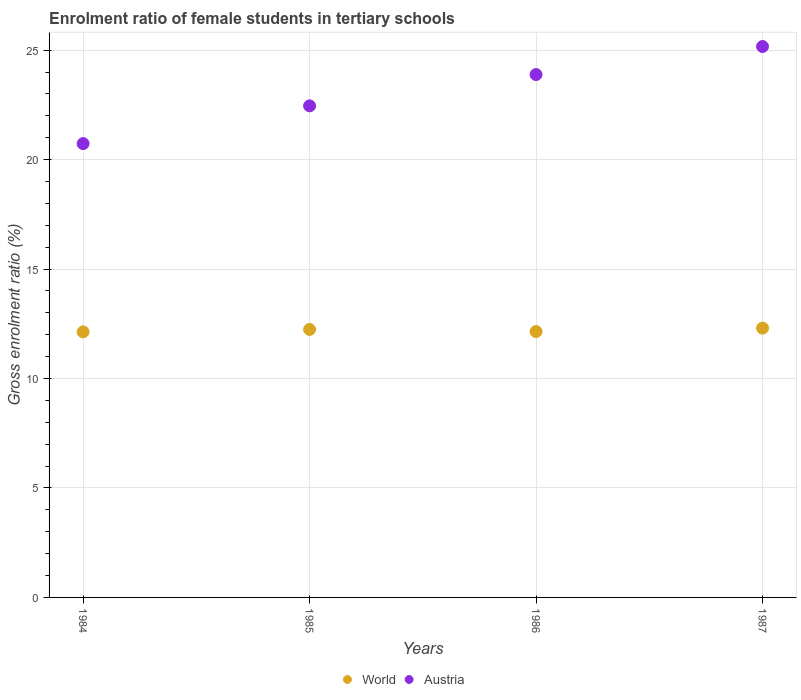How many different coloured dotlines are there?
Your answer should be compact. 2. What is the enrolment ratio of female students in tertiary schools in Austria in 1987?
Ensure brevity in your answer.  25.17. Across all years, what is the maximum enrolment ratio of female students in tertiary schools in World?
Keep it short and to the point. 12.3. Across all years, what is the minimum enrolment ratio of female students in tertiary schools in World?
Make the answer very short. 12.13. In which year was the enrolment ratio of female students in tertiary schools in Austria maximum?
Provide a short and direct response. 1987. What is the total enrolment ratio of female students in tertiary schools in Austria in the graph?
Keep it short and to the point. 92.25. What is the difference between the enrolment ratio of female students in tertiary schools in Austria in 1986 and that in 1987?
Make the answer very short. -1.28. What is the difference between the enrolment ratio of female students in tertiary schools in Austria in 1985 and the enrolment ratio of female students in tertiary schools in World in 1984?
Make the answer very short. 10.33. What is the average enrolment ratio of female students in tertiary schools in Austria per year?
Offer a terse response. 23.06. In the year 1985, what is the difference between the enrolment ratio of female students in tertiary schools in Austria and enrolment ratio of female students in tertiary schools in World?
Offer a very short reply. 10.21. In how many years, is the enrolment ratio of female students in tertiary schools in Austria greater than 8 %?
Your answer should be very brief. 4. What is the ratio of the enrolment ratio of female students in tertiary schools in World in 1986 to that in 1987?
Give a very brief answer. 0.99. Is the difference between the enrolment ratio of female students in tertiary schools in Austria in 1984 and 1985 greater than the difference between the enrolment ratio of female students in tertiary schools in World in 1984 and 1985?
Make the answer very short. No. What is the difference between the highest and the second highest enrolment ratio of female students in tertiary schools in Austria?
Give a very brief answer. 1.28. What is the difference between the highest and the lowest enrolment ratio of female students in tertiary schools in Austria?
Your response must be concise. 4.44. In how many years, is the enrolment ratio of female students in tertiary schools in Austria greater than the average enrolment ratio of female students in tertiary schools in Austria taken over all years?
Your answer should be very brief. 2. Is the enrolment ratio of female students in tertiary schools in World strictly greater than the enrolment ratio of female students in tertiary schools in Austria over the years?
Ensure brevity in your answer.  No. Is the enrolment ratio of female students in tertiary schools in World strictly less than the enrolment ratio of female students in tertiary schools in Austria over the years?
Offer a very short reply. Yes. How many dotlines are there?
Your response must be concise. 2. How many years are there in the graph?
Ensure brevity in your answer.  4. Does the graph contain any zero values?
Provide a short and direct response. No. How many legend labels are there?
Ensure brevity in your answer.  2. What is the title of the graph?
Your answer should be compact. Enrolment ratio of female students in tertiary schools. Does "Latin America(all income levels)" appear as one of the legend labels in the graph?
Your response must be concise. No. What is the label or title of the X-axis?
Provide a succinct answer. Years. What is the Gross enrolment ratio (%) of World in 1984?
Provide a succinct answer. 12.13. What is the Gross enrolment ratio (%) of Austria in 1984?
Your answer should be very brief. 20.73. What is the Gross enrolment ratio (%) in World in 1985?
Your answer should be compact. 12.24. What is the Gross enrolment ratio (%) of Austria in 1985?
Keep it short and to the point. 22.46. What is the Gross enrolment ratio (%) of World in 1986?
Your response must be concise. 12.15. What is the Gross enrolment ratio (%) of Austria in 1986?
Your response must be concise. 23.89. What is the Gross enrolment ratio (%) of World in 1987?
Offer a terse response. 12.3. What is the Gross enrolment ratio (%) in Austria in 1987?
Offer a very short reply. 25.17. Across all years, what is the maximum Gross enrolment ratio (%) of World?
Your answer should be very brief. 12.3. Across all years, what is the maximum Gross enrolment ratio (%) of Austria?
Your response must be concise. 25.17. Across all years, what is the minimum Gross enrolment ratio (%) in World?
Provide a succinct answer. 12.13. Across all years, what is the minimum Gross enrolment ratio (%) in Austria?
Keep it short and to the point. 20.73. What is the total Gross enrolment ratio (%) of World in the graph?
Your answer should be compact. 48.83. What is the total Gross enrolment ratio (%) in Austria in the graph?
Keep it short and to the point. 92.25. What is the difference between the Gross enrolment ratio (%) of World in 1984 and that in 1985?
Your response must be concise. -0.11. What is the difference between the Gross enrolment ratio (%) of Austria in 1984 and that in 1985?
Keep it short and to the point. -1.72. What is the difference between the Gross enrolment ratio (%) of World in 1984 and that in 1986?
Your answer should be compact. -0.02. What is the difference between the Gross enrolment ratio (%) in Austria in 1984 and that in 1986?
Offer a very short reply. -3.15. What is the difference between the Gross enrolment ratio (%) of World in 1984 and that in 1987?
Offer a terse response. -0.17. What is the difference between the Gross enrolment ratio (%) in Austria in 1984 and that in 1987?
Offer a terse response. -4.44. What is the difference between the Gross enrolment ratio (%) in World in 1985 and that in 1986?
Make the answer very short. 0.1. What is the difference between the Gross enrolment ratio (%) in Austria in 1985 and that in 1986?
Your answer should be compact. -1.43. What is the difference between the Gross enrolment ratio (%) of World in 1985 and that in 1987?
Ensure brevity in your answer.  -0.06. What is the difference between the Gross enrolment ratio (%) of Austria in 1985 and that in 1987?
Make the answer very short. -2.71. What is the difference between the Gross enrolment ratio (%) in World in 1986 and that in 1987?
Your answer should be compact. -0.16. What is the difference between the Gross enrolment ratio (%) of Austria in 1986 and that in 1987?
Ensure brevity in your answer.  -1.28. What is the difference between the Gross enrolment ratio (%) of World in 1984 and the Gross enrolment ratio (%) of Austria in 1985?
Provide a short and direct response. -10.33. What is the difference between the Gross enrolment ratio (%) in World in 1984 and the Gross enrolment ratio (%) in Austria in 1986?
Offer a terse response. -11.76. What is the difference between the Gross enrolment ratio (%) in World in 1984 and the Gross enrolment ratio (%) in Austria in 1987?
Provide a succinct answer. -13.04. What is the difference between the Gross enrolment ratio (%) of World in 1985 and the Gross enrolment ratio (%) of Austria in 1986?
Provide a short and direct response. -11.64. What is the difference between the Gross enrolment ratio (%) of World in 1985 and the Gross enrolment ratio (%) of Austria in 1987?
Ensure brevity in your answer.  -12.93. What is the difference between the Gross enrolment ratio (%) in World in 1986 and the Gross enrolment ratio (%) in Austria in 1987?
Keep it short and to the point. -13.02. What is the average Gross enrolment ratio (%) of World per year?
Your response must be concise. 12.21. What is the average Gross enrolment ratio (%) of Austria per year?
Provide a succinct answer. 23.06. In the year 1984, what is the difference between the Gross enrolment ratio (%) in World and Gross enrolment ratio (%) in Austria?
Ensure brevity in your answer.  -8.6. In the year 1985, what is the difference between the Gross enrolment ratio (%) in World and Gross enrolment ratio (%) in Austria?
Provide a short and direct response. -10.21. In the year 1986, what is the difference between the Gross enrolment ratio (%) in World and Gross enrolment ratio (%) in Austria?
Provide a short and direct response. -11.74. In the year 1987, what is the difference between the Gross enrolment ratio (%) in World and Gross enrolment ratio (%) in Austria?
Your answer should be very brief. -12.86. What is the ratio of the Gross enrolment ratio (%) in World in 1984 to that in 1985?
Your answer should be compact. 0.99. What is the ratio of the Gross enrolment ratio (%) of Austria in 1984 to that in 1985?
Ensure brevity in your answer.  0.92. What is the ratio of the Gross enrolment ratio (%) of Austria in 1984 to that in 1986?
Offer a very short reply. 0.87. What is the ratio of the Gross enrolment ratio (%) of World in 1984 to that in 1987?
Offer a terse response. 0.99. What is the ratio of the Gross enrolment ratio (%) in Austria in 1984 to that in 1987?
Offer a terse response. 0.82. What is the ratio of the Gross enrolment ratio (%) of World in 1985 to that in 1986?
Provide a short and direct response. 1.01. What is the ratio of the Gross enrolment ratio (%) of Austria in 1985 to that in 1986?
Your answer should be compact. 0.94. What is the ratio of the Gross enrolment ratio (%) in World in 1985 to that in 1987?
Keep it short and to the point. 1. What is the ratio of the Gross enrolment ratio (%) of Austria in 1985 to that in 1987?
Make the answer very short. 0.89. What is the ratio of the Gross enrolment ratio (%) of World in 1986 to that in 1987?
Provide a short and direct response. 0.99. What is the ratio of the Gross enrolment ratio (%) in Austria in 1986 to that in 1987?
Offer a terse response. 0.95. What is the difference between the highest and the second highest Gross enrolment ratio (%) of World?
Offer a very short reply. 0.06. What is the difference between the highest and the second highest Gross enrolment ratio (%) of Austria?
Your response must be concise. 1.28. What is the difference between the highest and the lowest Gross enrolment ratio (%) of World?
Your answer should be compact. 0.17. What is the difference between the highest and the lowest Gross enrolment ratio (%) of Austria?
Ensure brevity in your answer.  4.44. 